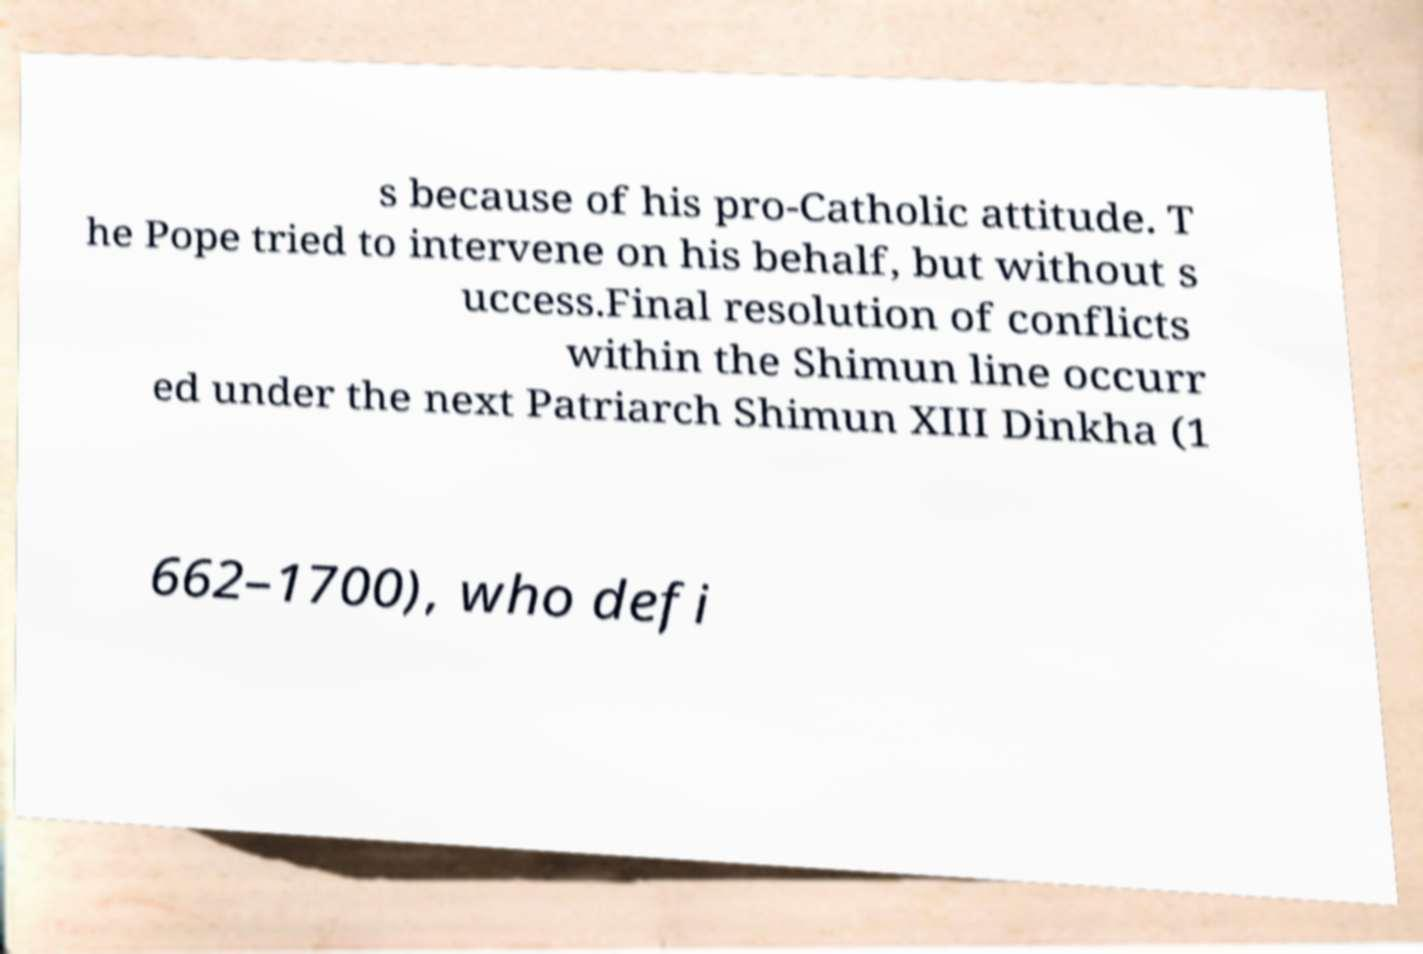For documentation purposes, I need the text within this image transcribed. Could you provide that? s because of his pro-Catholic attitude. T he Pope tried to intervene on his behalf, but without s uccess.Final resolution of conflicts within the Shimun line occurr ed under the next Patriarch Shimun XIII Dinkha (1 662–1700), who defi 